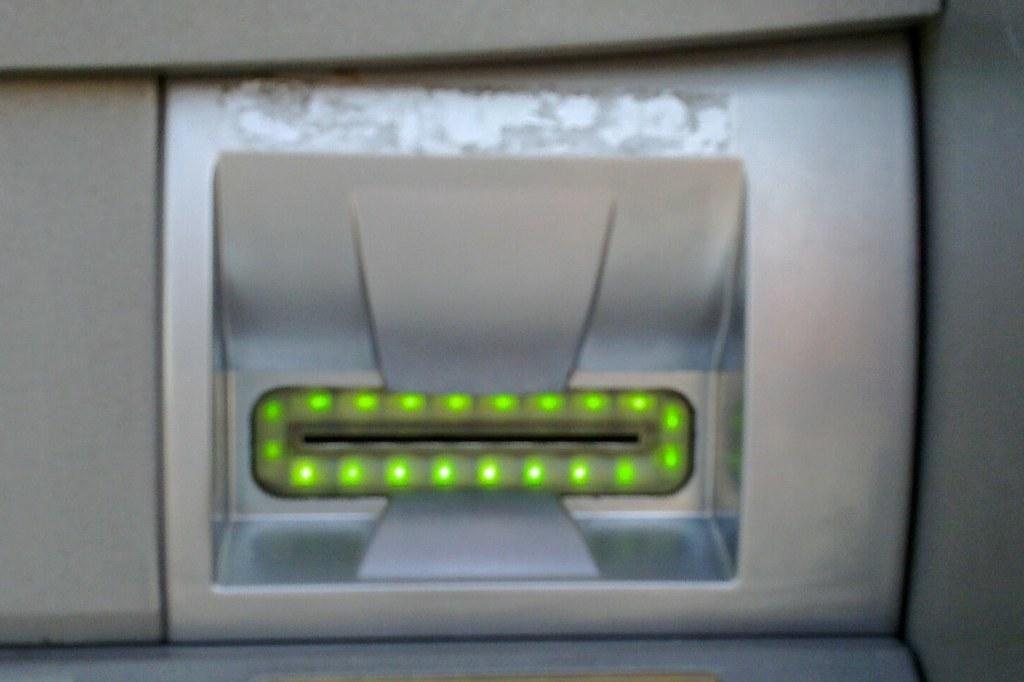What is the overall quality of the image? The image is slightly blurred. What type of machine is present in the image? There is an ATM machine in the image. What feature is present on the ATM machine? The ATM machine has a card slot. Can you see any zebras or quills in the image? No, there are no zebras or quills present in the image. Is there any snow visible in the image? No, there is no snow visible in the image. 